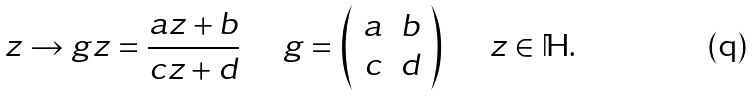<formula> <loc_0><loc_0><loc_500><loc_500>z \rightarrow g z = \frac { a z + b } { c z + d } \quad \ g = \left ( \begin{array} { c c } a & b \\ c & d \\ \end{array} \right ) \quad \ z \in \mathbb { H } .</formula> 